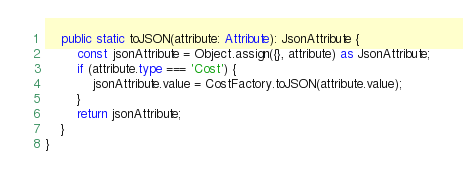Convert code to text. <code><loc_0><loc_0><loc_500><loc_500><_TypeScript_>    public static toJSON(attribute: Attribute): JsonAttribute {
        const jsonAttribute = Object.assign({}, attribute) as JsonAttribute;
        if (attribute.type === 'Cost') {
            jsonAttribute.value = CostFactory.toJSON(attribute.value);
        }
        return jsonAttribute;
    }
}
</code> 